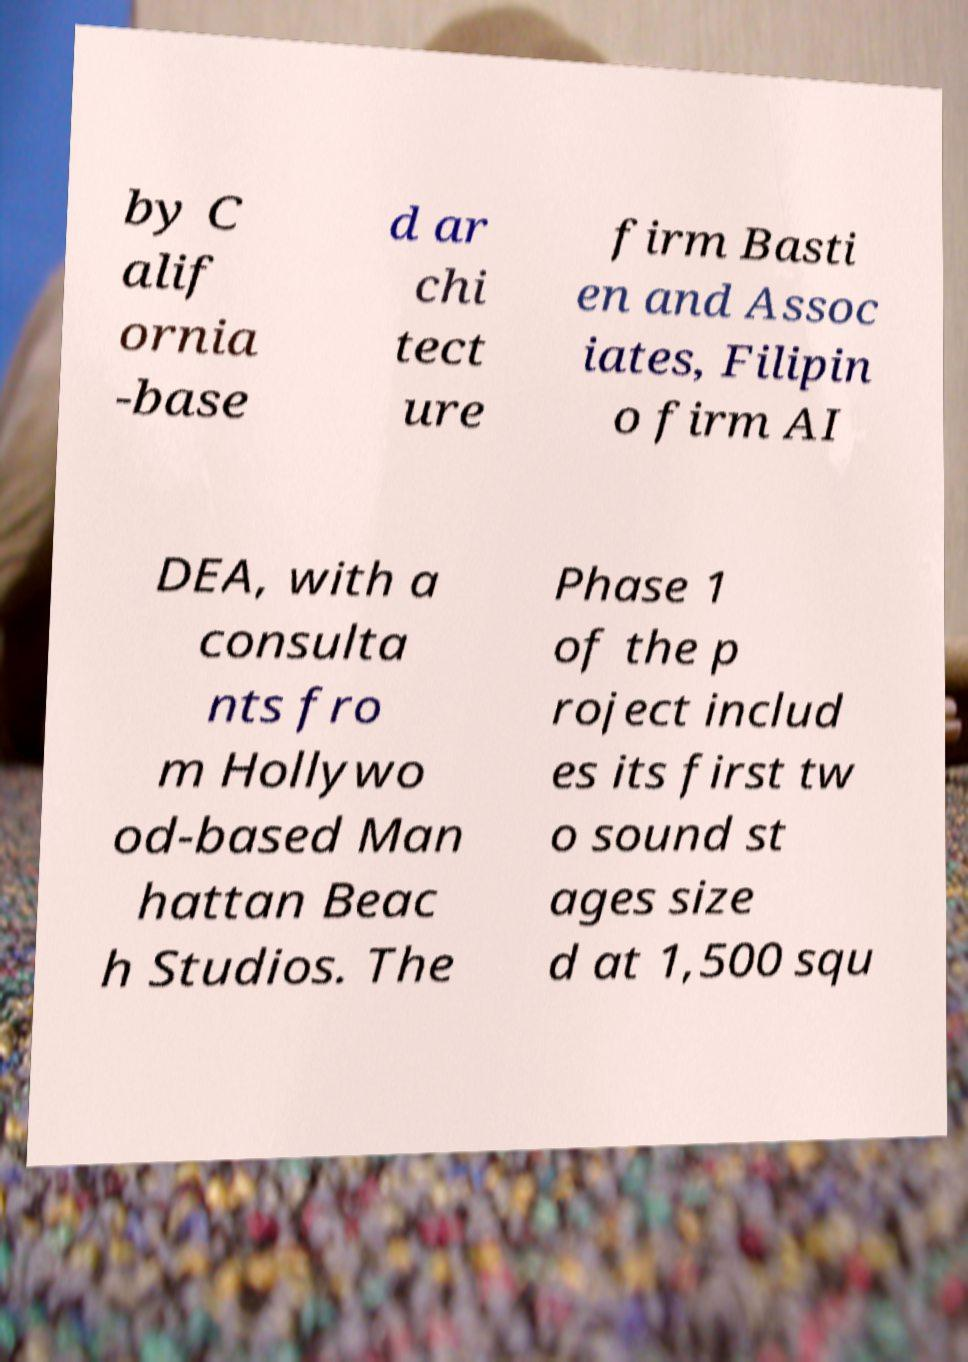Please read and relay the text visible in this image. What does it say? by C alif ornia -base d ar chi tect ure firm Basti en and Assoc iates, Filipin o firm AI DEA, with a consulta nts fro m Hollywo od-based Man hattan Beac h Studios. The Phase 1 of the p roject includ es its first tw o sound st ages size d at 1,500 squ 